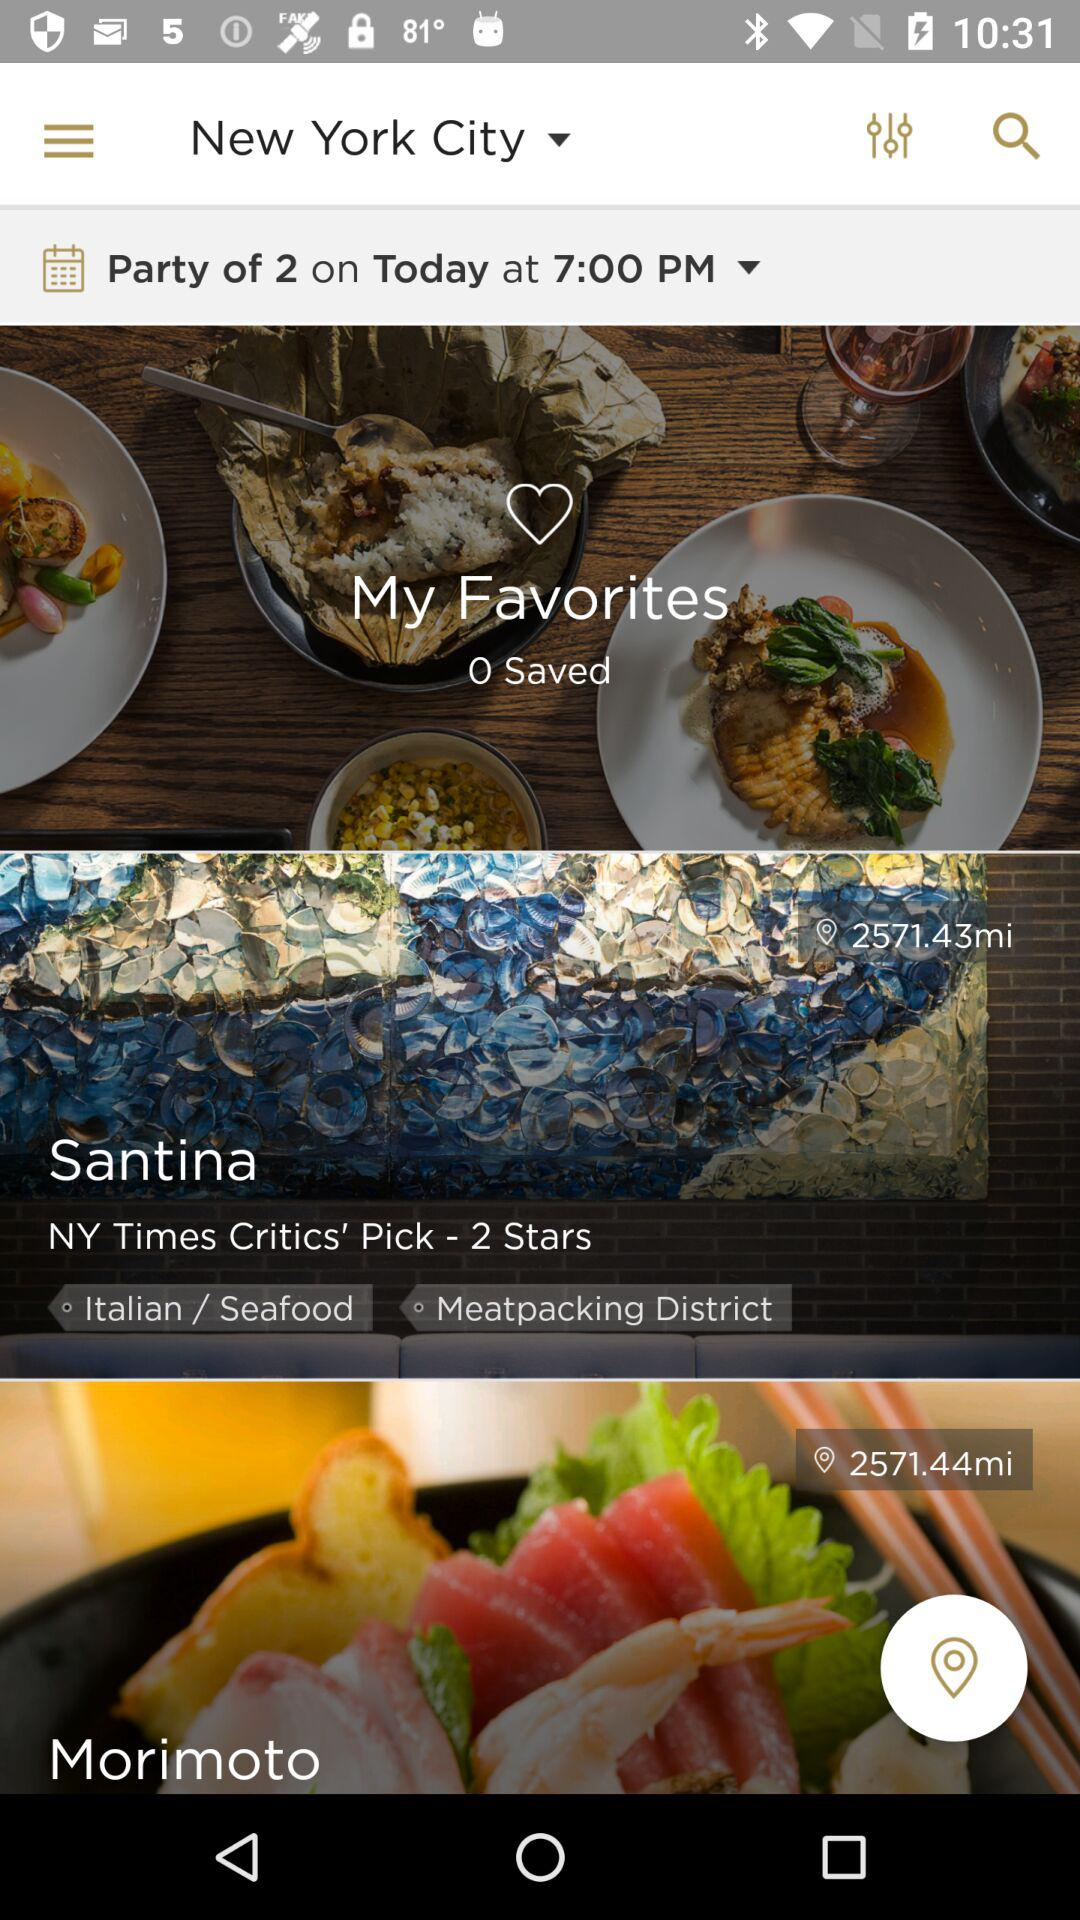What is the distance between my location and Santina? The distance is 2571.43 miles. 